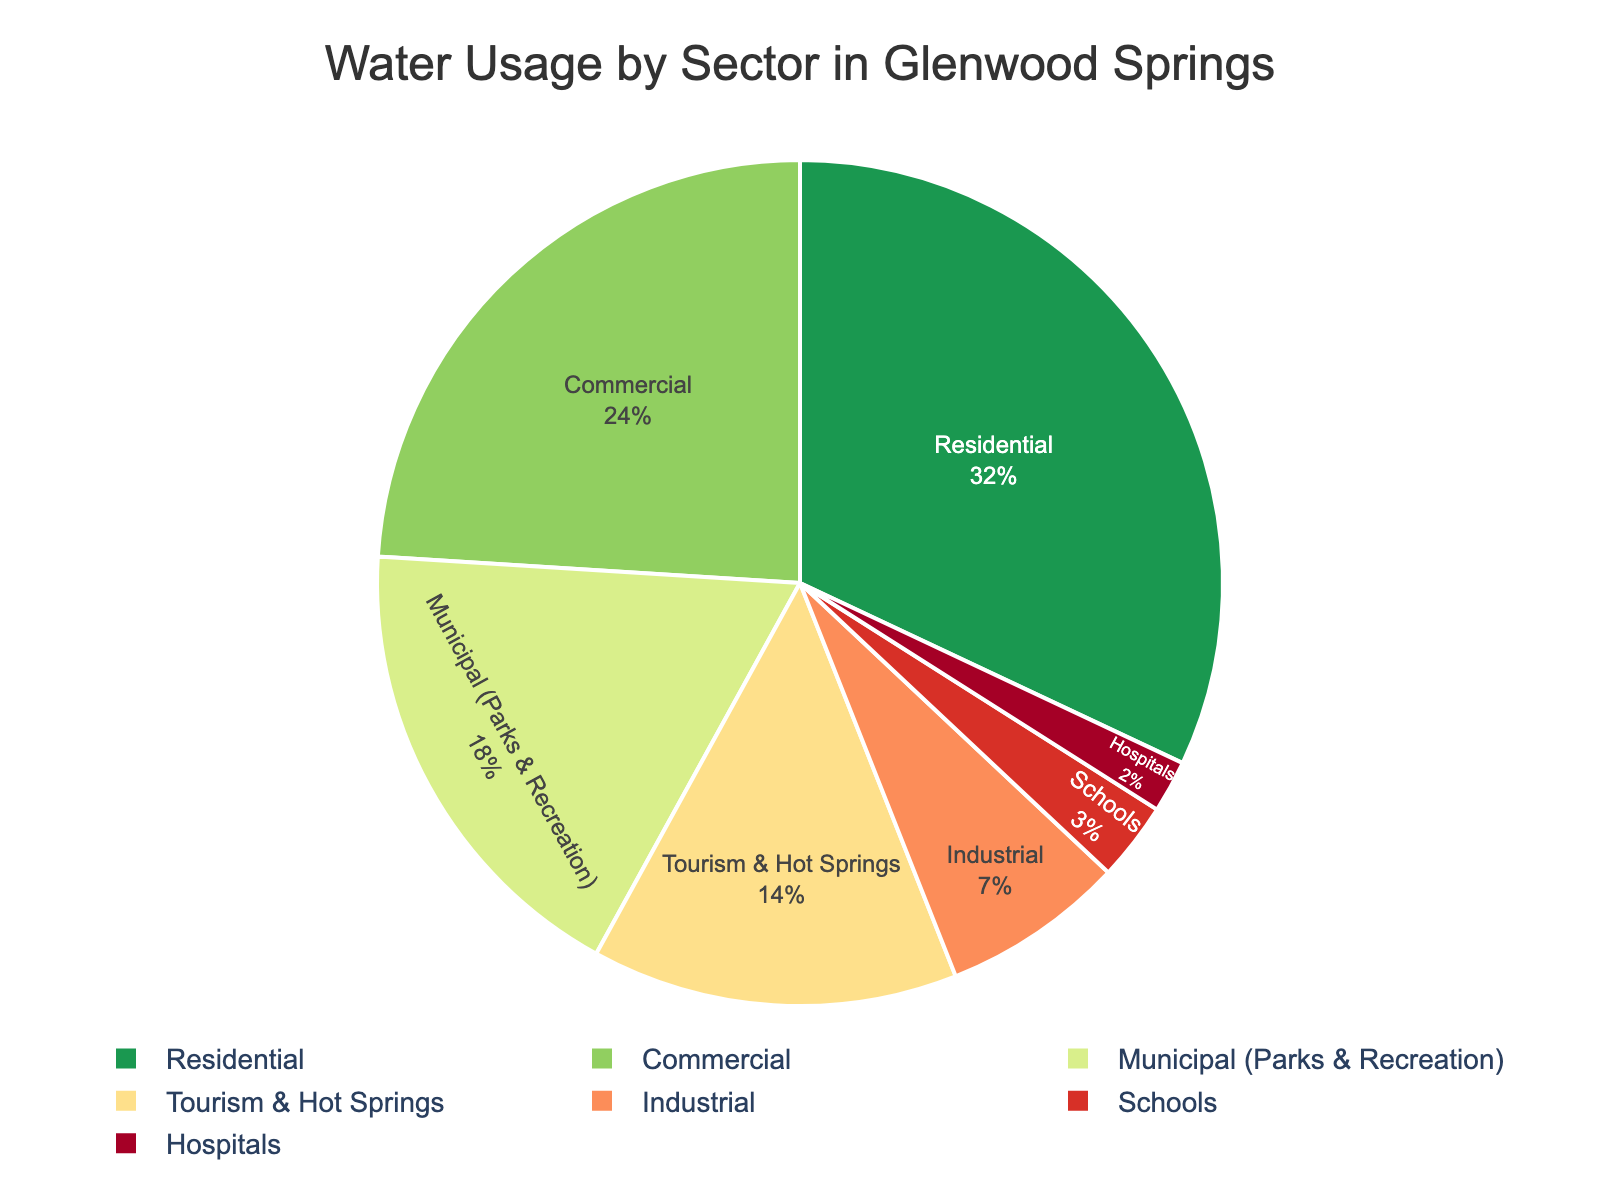What's the largest sector of water usage in Glenwood Springs? The pie chart clearly shows the percentage for each sector. By looking for the sector with the largest slice, we see that the Residential sector uses 32% of the water.
Answer: Residential What is the combined percentage of water usage for Schools and Hospitals? We need to add the percentages for Schools and Hospitals. According to the chart, Schools use 3% and Hospitals use 2%. So, the total is 3% + 2% = 5%.
Answer: 5% How does the water usage of the Commercial sector compare to the Tourism & Hot Springs sector? The pie chart shows the percentages for each sector. The Commercial sector uses 24% while the Tourism & Hot Springs sector uses 14%. Therefore, the Commercial sector uses more water.
Answer: Commercial uses more What sectors use less than 10% of the total water? From the pie chart, we check for sectors with less than 10%. The Industrial sector uses 7%, Schools use 3%, and Hospitals use 2%. These three sectors are the ones using less than 10%.
Answer: Industrial, Schools, Hospitals Which sector has a higher water usage: Municipal (Parks & Recreation) or Tourism & Hot Springs? By looking at the pie chart, we see that Municipal (Parks & Recreation) uses 18%, and Tourism & Hot Springs uses 14%. Therefore, the Municipal sector has higher water usage.
Answer: Municipal (Parks & Recreation) What is the total percentage of water usage for Residential, Industrial, and Commercial sectors combined? We need to add the percentages of Residential (32%), Industrial (7%), and Commercial (24%). The total is 32% + 7% + 24% = 63%.
Answer: 63% Which sector's slice is colored in a deep green shade in the pie chart? In the pie chart, the color assigned to each sector corresponds to a shade of green or related colors. The deep green shade is used for the Residential sector.
Answer: Residential Is the percentage of water usage by Schools higher than by Hospitals? According to the pie chart, Schools use 3% of the water, while Hospitals use 2%. So, the water usage by Schools is higher than by Hospitals.
Answer: Yes What is the difference in water usage between the Tourism & Hot Springs and Industrial sectors? We find the percentages for Tourism & Hot Springs (14%) and Industrial (7%). The difference is 14% - 7% = 7%.
Answer: 7% 